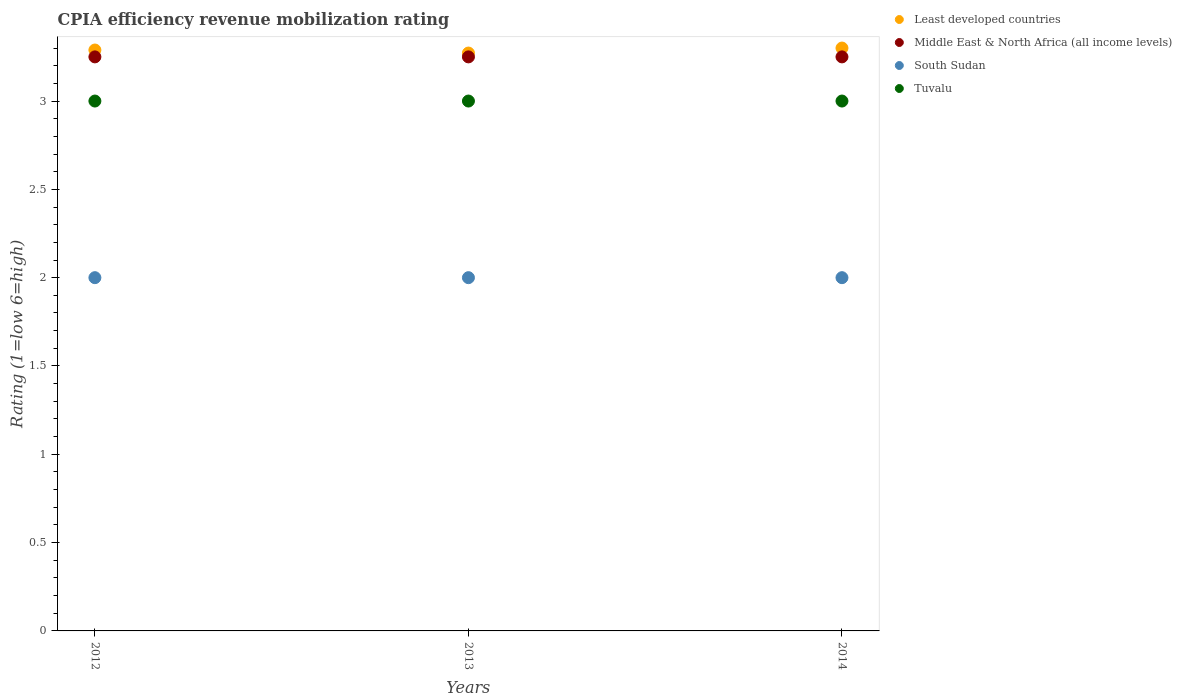Is the number of dotlines equal to the number of legend labels?
Make the answer very short. Yes. What is the CPIA rating in Least developed countries in 2013?
Provide a succinct answer. 3.27. Across all years, what is the minimum CPIA rating in Tuvalu?
Provide a succinct answer. 3. In which year was the CPIA rating in Least developed countries minimum?
Ensure brevity in your answer.  2013. What is the total CPIA rating in Middle East & North Africa (all income levels) in the graph?
Ensure brevity in your answer.  9.75. What is the difference between the CPIA rating in South Sudan in 2013 and the CPIA rating in Least developed countries in 2012?
Your answer should be compact. -1.29. What is the average CPIA rating in Least developed countries per year?
Offer a very short reply. 3.29. In the year 2014, what is the difference between the CPIA rating in Least developed countries and CPIA rating in Tuvalu?
Provide a succinct answer. 0.3. In how many years, is the CPIA rating in Tuvalu greater than 0.1?
Your response must be concise. 3. Is the CPIA rating in Middle East & North Africa (all income levels) in 2013 less than that in 2014?
Offer a very short reply. No. Is the difference between the CPIA rating in Least developed countries in 2013 and 2014 greater than the difference between the CPIA rating in Tuvalu in 2013 and 2014?
Your answer should be very brief. No. What is the difference between the highest and the second highest CPIA rating in Tuvalu?
Provide a succinct answer. 0. What is the difference between the highest and the lowest CPIA rating in Middle East & North Africa (all income levels)?
Ensure brevity in your answer.  0. In how many years, is the CPIA rating in South Sudan greater than the average CPIA rating in South Sudan taken over all years?
Offer a very short reply. 0. Is the sum of the CPIA rating in Tuvalu in 2013 and 2014 greater than the maximum CPIA rating in Least developed countries across all years?
Give a very brief answer. Yes. Is it the case that in every year, the sum of the CPIA rating in South Sudan and CPIA rating in Tuvalu  is greater than the CPIA rating in Least developed countries?
Ensure brevity in your answer.  Yes. Are the values on the major ticks of Y-axis written in scientific E-notation?
Your answer should be compact. No. Does the graph contain grids?
Offer a terse response. No. Where does the legend appear in the graph?
Provide a short and direct response. Top right. How many legend labels are there?
Your answer should be very brief. 4. How are the legend labels stacked?
Your answer should be compact. Vertical. What is the title of the graph?
Provide a succinct answer. CPIA efficiency revenue mobilization rating. What is the label or title of the X-axis?
Provide a succinct answer. Years. What is the label or title of the Y-axis?
Your answer should be very brief. Rating (1=low 6=high). What is the Rating (1=low 6=high) of Least developed countries in 2012?
Give a very brief answer. 3.29. What is the Rating (1=low 6=high) in South Sudan in 2012?
Ensure brevity in your answer.  2. What is the Rating (1=low 6=high) of Least developed countries in 2013?
Ensure brevity in your answer.  3.27. What is the Rating (1=low 6=high) of Middle East & North Africa (all income levels) in 2013?
Keep it short and to the point. 3.25. What is the Rating (1=low 6=high) of Least developed countries in 2014?
Keep it short and to the point. 3.3. What is the Rating (1=low 6=high) in Middle East & North Africa (all income levels) in 2014?
Keep it short and to the point. 3.25. Across all years, what is the maximum Rating (1=low 6=high) in Middle East & North Africa (all income levels)?
Ensure brevity in your answer.  3.25. Across all years, what is the minimum Rating (1=low 6=high) in Least developed countries?
Keep it short and to the point. 3.27. Across all years, what is the minimum Rating (1=low 6=high) of Middle East & North Africa (all income levels)?
Ensure brevity in your answer.  3.25. Across all years, what is the minimum Rating (1=low 6=high) of Tuvalu?
Offer a terse response. 3. What is the total Rating (1=low 6=high) of Least developed countries in the graph?
Provide a short and direct response. 9.86. What is the total Rating (1=low 6=high) of Middle East & North Africa (all income levels) in the graph?
Keep it short and to the point. 9.75. What is the difference between the Rating (1=low 6=high) of Least developed countries in 2012 and that in 2013?
Your response must be concise. 0.02. What is the difference between the Rating (1=low 6=high) in Tuvalu in 2012 and that in 2013?
Your answer should be very brief. 0. What is the difference between the Rating (1=low 6=high) in Least developed countries in 2012 and that in 2014?
Your answer should be compact. -0.01. What is the difference between the Rating (1=low 6=high) in Middle East & North Africa (all income levels) in 2012 and that in 2014?
Ensure brevity in your answer.  0. What is the difference between the Rating (1=low 6=high) of South Sudan in 2012 and that in 2014?
Your answer should be compact. 0. What is the difference between the Rating (1=low 6=high) of Least developed countries in 2013 and that in 2014?
Ensure brevity in your answer.  -0.03. What is the difference between the Rating (1=low 6=high) of South Sudan in 2013 and that in 2014?
Make the answer very short. 0. What is the difference between the Rating (1=low 6=high) of Least developed countries in 2012 and the Rating (1=low 6=high) of Middle East & North Africa (all income levels) in 2013?
Your answer should be very brief. 0.04. What is the difference between the Rating (1=low 6=high) of Least developed countries in 2012 and the Rating (1=low 6=high) of South Sudan in 2013?
Your answer should be compact. 1.29. What is the difference between the Rating (1=low 6=high) in Least developed countries in 2012 and the Rating (1=low 6=high) in Tuvalu in 2013?
Ensure brevity in your answer.  0.29. What is the difference between the Rating (1=low 6=high) in Middle East & North Africa (all income levels) in 2012 and the Rating (1=low 6=high) in Tuvalu in 2013?
Your response must be concise. 0.25. What is the difference between the Rating (1=low 6=high) of South Sudan in 2012 and the Rating (1=low 6=high) of Tuvalu in 2013?
Make the answer very short. -1. What is the difference between the Rating (1=low 6=high) in Least developed countries in 2012 and the Rating (1=low 6=high) in Middle East & North Africa (all income levels) in 2014?
Keep it short and to the point. 0.04. What is the difference between the Rating (1=low 6=high) in Least developed countries in 2012 and the Rating (1=low 6=high) in South Sudan in 2014?
Give a very brief answer. 1.29. What is the difference between the Rating (1=low 6=high) in Least developed countries in 2012 and the Rating (1=low 6=high) in Tuvalu in 2014?
Ensure brevity in your answer.  0.29. What is the difference between the Rating (1=low 6=high) in Middle East & North Africa (all income levels) in 2012 and the Rating (1=low 6=high) in South Sudan in 2014?
Give a very brief answer. 1.25. What is the difference between the Rating (1=low 6=high) of Middle East & North Africa (all income levels) in 2012 and the Rating (1=low 6=high) of Tuvalu in 2014?
Your response must be concise. 0.25. What is the difference between the Rating (1=low 6=high) of Least developed countries in 2013 and the Rating (1=low 6=high) of Middle East & North Africa (all income levels) in 2014?
Offer a terse response. 0.02. What is the difference between the Rating (1=low 6=high) of Least developed countries in 2013 and the Rating (1=low 6=high) of South Sudan in 2014?
Your answer should be compact. 1.27. What is the difference between the Rating (1=low 6=high) in Least developed countries in 2013 and the Rating (1=low 6=high) in Tuvalu in 2014?
Your response must be concise. 0.27. What is the difference between the Rating (1=low 6=high) in Middle East & North Africa (all income levels) in 2013 and the Rating (1=low 6=high) in South Sudan in 2014?
Make the answer very short. 1.25. What is the difference between the Rating (1=low 6=high) of Middle East & North Africa (all income levels) in 2013 and the Rating (1=low 6=high) of Tuvalu in 2014?
Ensure brevity in your answer.  0.25. What is the average Rating (1=low 6=high) of Least developed countries per year?
Keep it short and to the point. 3.29. What is the average Rating (1=low 6=high) of Middle East & North Africa (all income levels) per year?
Your answer should be compact. 3.25. What is the average Rating (1=low 6=high) in South Sudan per year?
Provide a succinct answer. 2. What is the average Rating (1=low 6=high) of Tuvalu per year?
Provide a succinct answer. 3. In the year 2012, what is the difference between the Rating (1=low 6=high) in Least developed countries and Rating (1=low 6=high) in Middle East & North Africa (all income levels)?
Keep it short and to the point. 0.04. In the year 2012, what is the difference between the Rating (1=low 6=high) of Least developed countries and Rating (1=low 6=high) of South Sudan?
Offer a terse response. 1.29. In the year 2012, what is the difference between the Rating (1=low 6=high) of Least developed countries and Rating (1=low 6=high) of Tuvalu?
Make the answer very short. 0.29. In the year 2012, what is the difference between the Rating (1=low 6=high) in Middle East & North Africa (all income levels) and Rating (1=low 6=high) in South Sudan?
Your response must be concise. 1.25. In the year 2012, what is the difference between the Rating (1=low 6=high) of Middle East & North Africa (all income levels) and Rating (1=low 6=high) of Tuvalu?
Provide a succinct answer. 0.25. In the year 2012, what is the difference between the Rating (1=low 6=high) of South Sudan and Rating (1=low 6=high) of Tuvalu?
Your answer should be compact. -1. In the year 2013, what is the difference between the Rating (1=low 6=high) in Least developed countries and Rating (1=low 6=high) in Middle East & North Africa (all income levels)?
Offer a terse response. 0.02. In the year 2013, what is the difference between the Rating (1=low 6=high) of Least developed countries and Rating (1=low 6=high) of South Sudan?
Provide a short and direct response. 1.27. In the year 2013, what is the difference between the Rating (1=low 6=high) in Least developed countries and Rating (1=low 6=high) in Tuvalu?
Your response must be concise. 0.27. In the year 2013, what is the difference between the Rating (1=low 6=high) in South Sudan and Rating (1=low 6=high) in Tuvalu?
Give a very brief answer. -1. In the year 2014, what is the difference between the Rating (1=low 6=high) of Least developed countries and Rating (1=low 6=high) of Middle East & North Africa (all income levels)?
Make the answer very short. 0.05. In the year 2014, what is the difference between the Rating (1=low 6=high) of Least developed countries and Rating (1=low 6=high) of South Sudan?
Offer a terse response. 1.3. In the year 2014, what is the difference between the Rating (1=low 6=high) in Middle East & North Africa (all income levels) and Rating (1=low 6=high) in South Sudan?
Provide a short and direct response. 1.25. What is the ratio of the Rating (1=low 6=high) in Middle East & North Africa (all income levels) in 2012 to that in 2013?
Ensure brevity in your answer.  1. What is the ratio of the Rating (1=low 6=high) in South Sudan in 2012 to that in 2013?
Provide a succinct answer. 1. What is the ratio of the Rating (1=low 6=high) of Middle East & North Africa (all income levels) in 2012 to that in 2014?
Your answer should be compact. 1. What is the ratio of the Rating (1=low 6=high) in Tuvalu in 2012 to that in 2014?
Offer a very short reply. 1. What is the ratio of the Rating (1=low 6=high) in Least developed countries in 2013 to that in 2014?
Keep it short and to the point. 0.99. What is the ratio of the Rating (1=low 6=high) of Middle East & North Africa (all income levels) in 2013 to that in 2014?
Make the answer very short. 1. What is the ratio of the Rating (1=low 6=high) in South Sudan in 2013 to that in 2014?
Provide a succinct answer. 1. What is the ratio of the Rating (1=low 6=high) of Tuvalu in 2013 to that in 2014?
Give a very brief answer. 1. What is the difference between the highest and the second highest Rating (1=low 6=high) of Least developed countries?
Your response must be concise. 0.01. What is the difference between the highest and the second highest Rating (1=low 6=high) in Middle East & North Africa (all income levels)?
Offer a terse response. 0. What is the difference between the highest and the lowest Rating (1=low 6=high) in Least developed countries?
Your answer should be very brief. 0.03. 